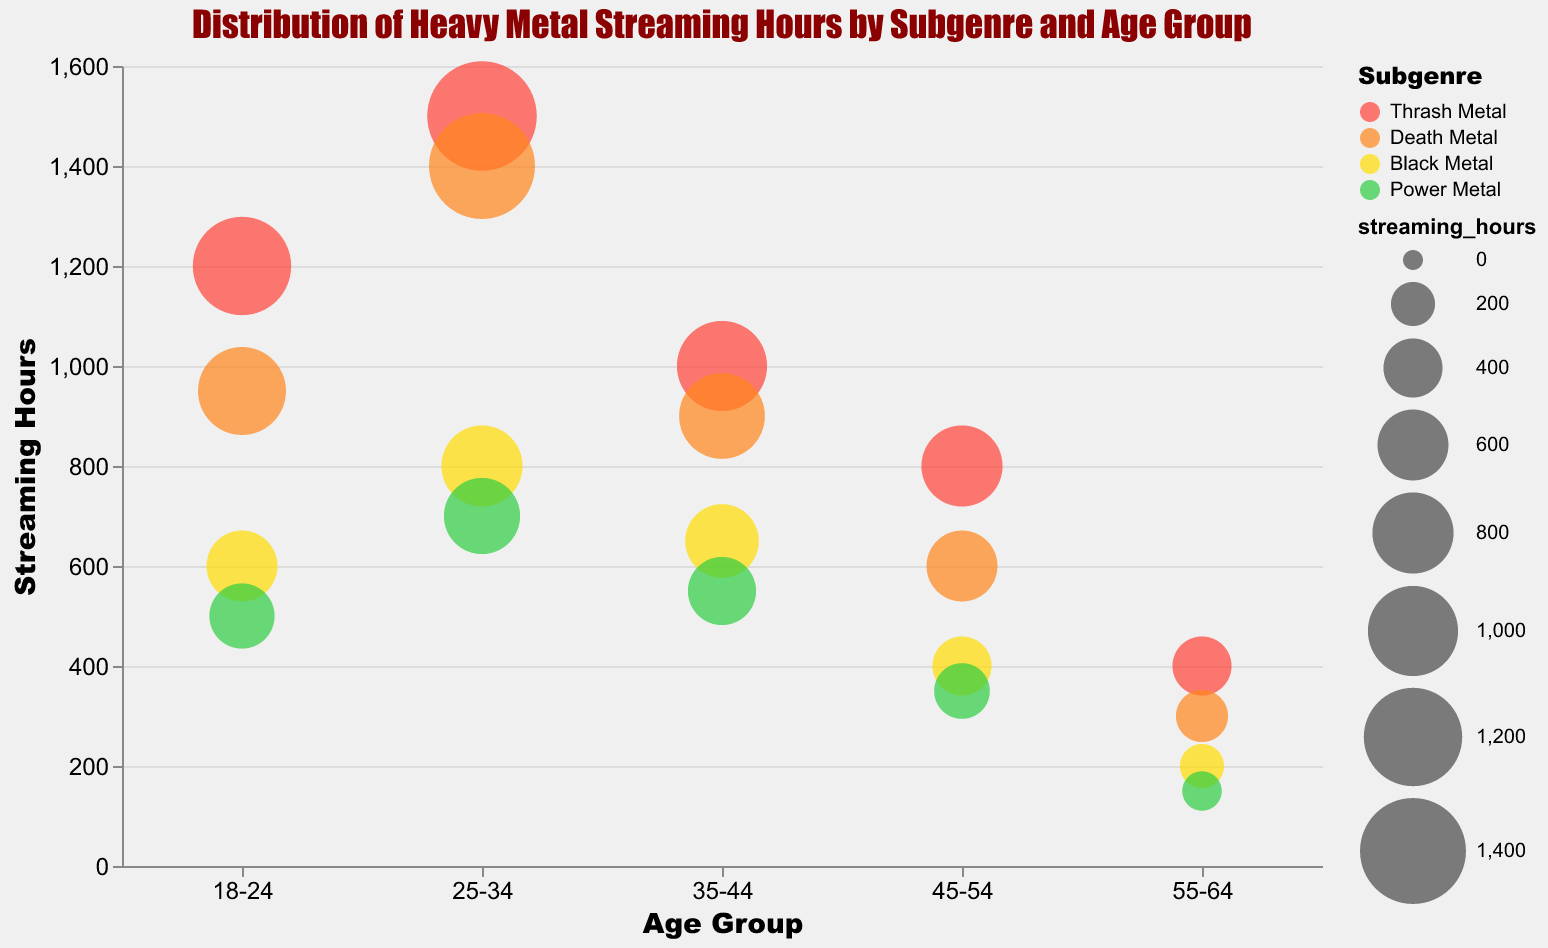What's the maximum streaming hours for Thrash Metal across all age groups? Look at the bubbles representing Thrash Metal in each age group and find the one with the largest size indicating the most streaming hours. The largest bubble for Thrash Metal appears in the 25-34 age group with 1500 streaming hours.
Answer: 1500 Which subgenre is the most popular among the 18-24 age group based on streaming hours? Look at the bubbles within the 18-24 age group and find the one with the largest size. The largest bubble in this age group is Thrash Metal with 1200 streaming hours.
Answer: Thrash Metal Comparing the 35-44 and 45-54 age groups, which age group has higher streaming hours for Death Metal? Compare the size of the bubbles for Death Metal in the 35-44 and 45-54 age groups. The bubble for 35-44 is larger than the one for 45-54, indicating higher streaming hours (900 vs. 600).
Answer: 35-44 What is the sum of streaming hours for Power Metal across all age groups? Add up all the streaming hours for Power Metal across the different age groups:
500 (18-24) + 700 (25-34) + 550 (35-44) + 350 (45-54) + 150 (55-64) = 2250.
Answer: 2250 Which age group has the least streaming hours for Black Metal? Find the smallest bubble representing Black Metal across all age groups. The smallest bubble is in the 55-64 age group with 200 streaming hours.
Answer: 55-64 How many age groups have more than 1000 streaming hours for Thrash Metal? Identify the bubbles for Thrash Metal and count how many exceed 1000 streaming hours. The bubbles in the 18-24, 25-34, and 35-44 age groups exceed 1000.
Answer: 3 Between Black Metal and Power Metal, which subgenre has a higher popularity ranking average across all age groups? Average the popularity rankings for each subgenre:
Black Metal: (9+5+6+8+6)/5 = 34/5 = 6.8
Power Metal: (7+8+9+5+8)/5 = 37/5 = 7.4
Black Metal has a higher average popularity ranking.
Answer: Black Metal What's the difference in streaming hours between the most popular subgenre for the 25-34 age group and the least popular for the same group? Identify the most popular (largest bubble) and least popular (smallest bubble) subgenres in the 25-34 age group:
Most popular: Thrash Metal (1500)
Least popular: Power Metal (700)
Difference: 1500 - 700 = 800.
Answer: 800 What's the average streaming hours for Death Metal across the 35-44 and 45-54 age groups? Calculate the average by adding the streaming hours of Death Metal in the two age groups and dividing by 2:
(900 + 600)/2 = 1500/2 = 750.
Answer: 750 